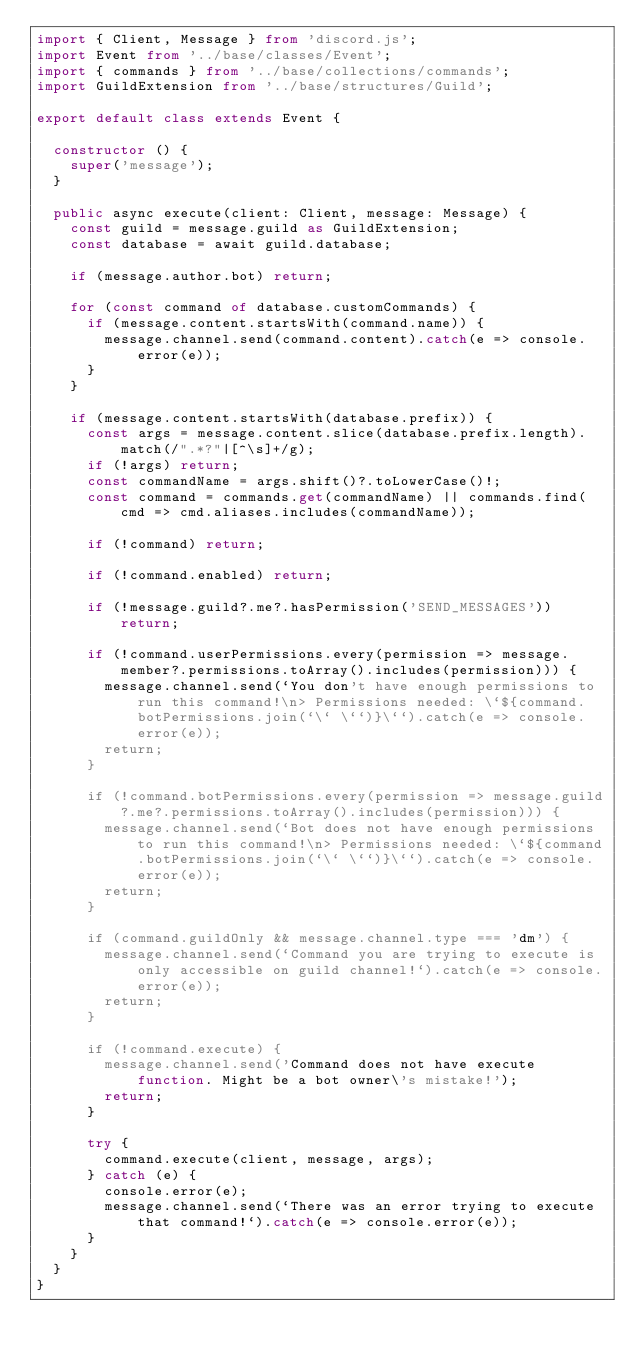Convert code to text. <code><loc_0><loc_0><loc_500><loc_500><_TypeScript_>import { Client, Message } from 'discord.js';
import Event from '../base/classes/Event';
import { commands } from '../base/collections/commands';
import GuildExtension from '../base/structures/Guild';

export default class extends Event {

  constructor () {
    super('message');
  }

  public async execute(client: Client, message: Message) {
    const guild = message.guild as GuildExtension;
    const database = await guild.database;

    if (message.author.bot) return;

    for (const command of database.customCommands) {
      if (message.content.startsWith(command.name)) {
        message.channel.send(command.content).catch(e => console.error(e));
      }
    }

    if (message.content.startsWith(database.prefix)) {
      const args = message.content.slice(database.prefix.length).match(/".*?"|[^\s]+/g);
      if (!args) return;
      const commandName = args.shift()?.toLowerCase()!;
      const command = commands.get(commandName) || commands.find(cmd => cmd.aliases.includes(commandName));

      if (!command) return;

      if (!command.enabled) return;

      if (!message.guild?.me?.hasPermission('SEND_MESSAGES')) return;

      if (!command.userPermissions.every(permission => message.member?.permissions.toArray().includes(permission))) {
        message.channel.send(`You don't have enough permissions to run this command!\n> Permissions needed: \`${command.botPermissions.join(`\` \``)}\``).catch(e => console.error(e));
        return;
      }

      if (!command.botPermissions.every(permission => message.guild?.me?.permissions.toArray().includes(permission))) {
        message.channel.send(`Bot does not have enough permissions to run this command!\n> Permissions needed: \`${command.botPermissions.join(`\` \``)}\``).catch(e => console.error(e));
        return;
      }

      if (command.guildOnly && message.channel.type === 'dm') {
        message.channel.send(`Command you are trying to execute is only accessible on guild channel!`).catch(e => console.error(e));
        return;
      }

      if (!command.execute) {
        message.channel.send('Command does not have execute function. Might be a bot owner\'s mistake!');
        return;
      }

      try {
        command.execute(client, message, args);
      } catch (e) {
        console.error(e);
        message.channel.send(`There was an error trying to execute that command!`).catch(e => console.error(e));
      }
    }
  }
}</code> 